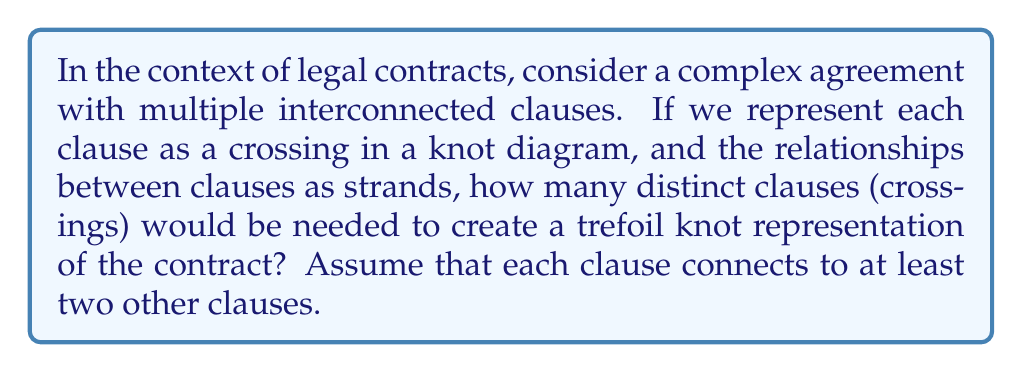Can you answer this question? To approach this problem, let's break it down step-by-step:

1. First, recall that a trefoil knot is the simplest non-trivial knot in knot theory. It's classified as a $(3,2)$ torus knot.

2. In a knot diagram, crossings represent points where one strand passes over or under another. In our analogy, these crossings represent individual clauses in the contract.

3. The trefoil knot has a minimum crossing number of 3. This means that in any diagram of a trefoil knot, there must be at least 3 crossings.

4. In the context of our contract analogy:
   - Each crossing (clause) must connect to at least two other clauses.
   - The strands connecting the crossings represent the relationships between clauses.

5. The trefoil knot can be represented by a diagram with exactly 3 crossings, where each crossing is connected to the other two.

6. Therefore, to create a trefoil knot representation of the contract, we need exactly 3 distinct clauses (crossings).

This representation allows us to visualize the interconnectedness of the contract clauses in a topological manner, highlighting the complexity and interrelations within the legal document.
Answer: 3 clauses (crossings) 